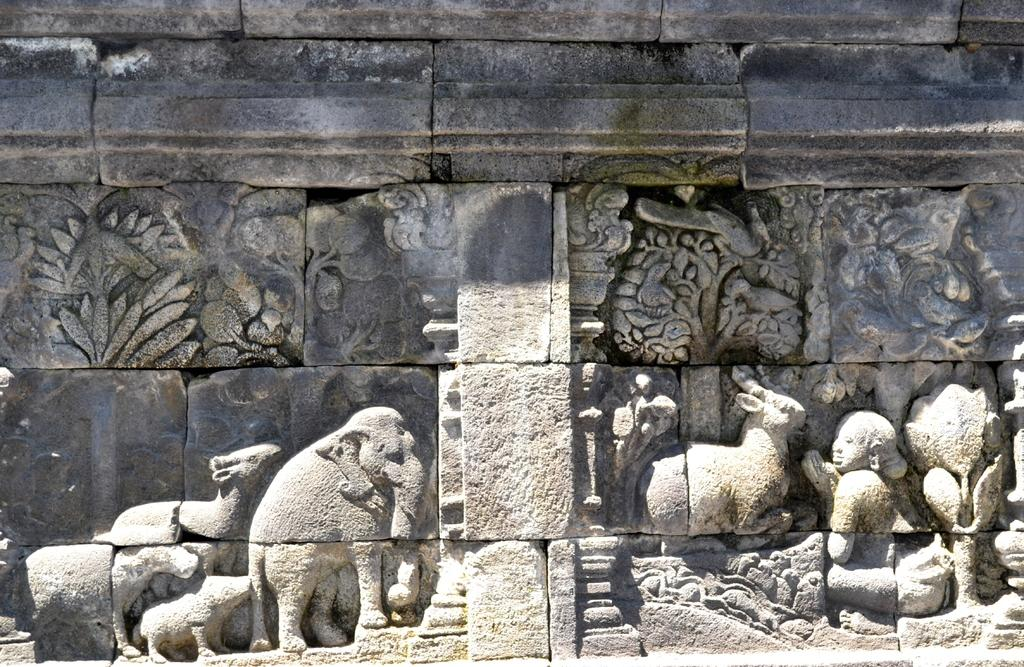What types of sculptures can be seen in the image? There are sculptures of animals and persons in the image. Where are the sculptures located? The sculptures are on a wall. What type of skin can be seen on the tub in the image? There is no tub or skin present in the image; it features sculptures of animals and persons on a wall. 